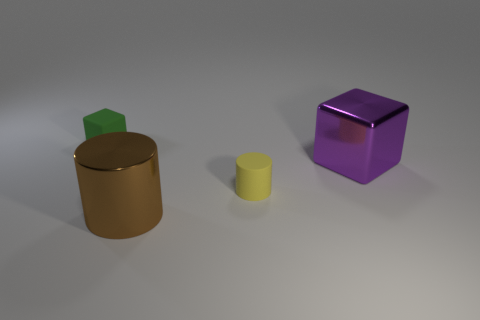Is there a big metal object that has the same color as the matte cylinder?
Provide a short and direct response. No. Do the small matte cube and the big metal cylinder have the same color?
Your answer should be very brief. No. How many big purple shiny cubes are behind the small matte thing behind the purple object?
Provide a succinct answer. 0. How many small red cubes have the same material as the brown thing?
Your response must be concise. 0. There is a small yellow cylinder; are there any big cylinders to the left of it?
Offer a terse response. Yes. What color is the cube that is the same size as the brown cylinder?
Make the answer very short. Purple. How many objects are either things that are to the right of the tiny green cube or big green metal balls?
Make the answer very short. 3. How big is the thing that is both behind the small cylinder and to the right of the tiny green rubber object?
Your answer should be very brief. Large. There is a big thing that is to the left of the small thing that is in front of the matte object that is to the left of the yellow object; what is its color?
Offer a terse response. Brown. What shape is the object that is both right of the big brown metal object and left of the purple metallic block?
Provide a succinct answer. Cylinder. 